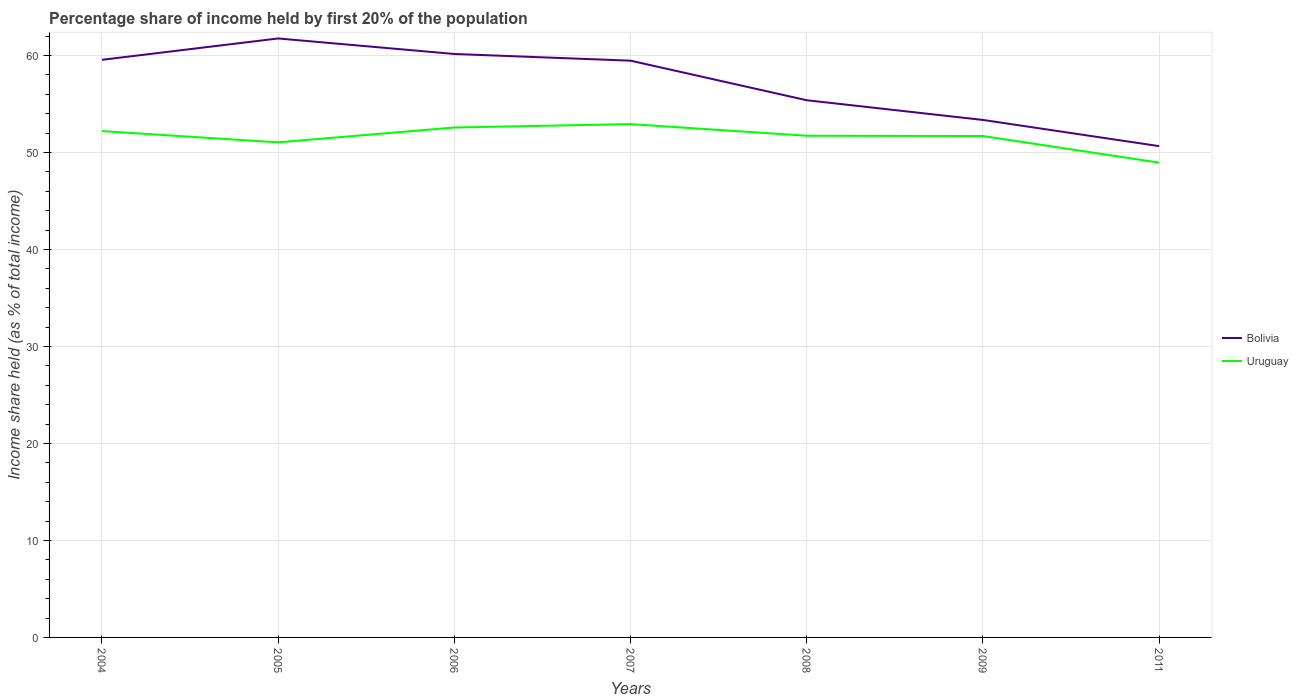How many different coloured lines are there?
Provide a succinct answer. 2. Does the line corresponding to Uruguay intersect with the line corresponding to Bolivia?
Provide a short and direct response. No. Across all years, what is the maximum share of income held by first 20% of the population in Uruguay?
Ensure brevity in your answer.  48.95. In which year was the share of income held by first 20% of the population in Bolivia maximum?
Your answer should be very brief. 2011. What is the total share of income held by first 20% of the population in Bolivia in the graph?
Your response must be concise. 0.09. What is the difference between the highest and the second highest share of income held by first 20% of the population in Uruguay?
Offer a very short reply. 3.97. Is the share of income held by first 20% of the population in Uruguay strictly greater than the share of income held by first 20% of the population in Bolivia over the years?
Provide a short and direct response. Yes. How many lines are there?
Offer a very short reply. 2. What is the difference between two consecutive major ticks on the Y-axis?
Your response must be concise. 10. Does the graph contain any zero values?
Your answer should be compact. No. Where does the legend appear in the graph?
Your answer should be compact. Center right. What is the title of the graph?
Keep it short and to the point. Percentage share of income held by first 20% of the population. What is the label or title of the X-axis?
Your answer should be compact. Years. What is the label or title of the Y-axis?
Ensure brevity in your answer.  Income share held (as % of total income). What is the Income share held (as % of total income) of Bolivia in 2004?
Make the answer very short. 59.55. What is the Income share held (as % of total income) of Uruguay in 2004?
Give a very brief answer. 52.2. What is the Income share held (as % of total income) in Bolivia in 2005?
Offer a terse response. 61.75. What is the Income share held (as % of total income) of Uruguay in 2005?
Keep it short and to the point. 51.04. What is the Income share held (as % of total income) of Bolivia in 2006?
Provide a succinct answer. 60.15. What is the Income share held (as % of total income) in Uruguay in 2006?
Provide a short and direct response. 52.57. What is the Income share held (as % of total income) of Bolivia in 2007?
Give a very brief answer. 59.46. What is the Income share held (as % of total income) of Uruguay in 2007?
Provide a short and direct response. 52.92. What is the Income share held (as % of total income) in Bolivia in 2008?
Make the answer very short. 55.38. What is the Income share held (as % of total income) in Uruguay in 2008?
Ensure brevity in your answer.  51.72. What is the Income share held (as % of total income) of Bolivia in 2009?
Make the answer very short. 53.35. What is the Income share held (as % of total income) in Uruguay in 2009?
Provide a short and direct response. 51.69. What is the Income share held (as % of total income) in Bolivia in 2011?
Your answer should be very brief. 50.65. What is the Income share held (as % of total income) in Uruguay in 2011?
Ensure brevity in your answer.  48.95. Across all years, what is the maximum Income share held (as % of total income) of Bolivia?
Ensure brevity in your answer.  61.75. Across all years, what is the maximum Income share held (as % of total income) in Uruguay?
Offer a very short reply. 52.92. Across all years, what is the minimum Income share held (as % of total income) in Bolivia?
Offer a terse response. 50.65. Across all years, what is the minimum Income share held (as % of total income) in Uruguay?
Ensure brevity in your answer.  48.95. What is the total Income share held (as % of total income) of Bolivia in the graph?
Offer a terse response. 400.29. What is the total Income share held (as % of total income) of Uruguay in the graph?
Give a very brief answer. 361.09. What is the difference between the Income share held (as % of total income) in Uruguay in 2004 and that in 2005?
Ensure brevity in your answer.  1.16. What is the difference between the Income share held (as % of total income) of Uruguay in 2004 and that in 2006?
Your answer should be very brief. -0.37. What is the difference between the Income share held (as % of total income) in Bolivia in 2004 and that in 2007?
Your response must be concise. 0.09. What is the difference between the Income share held (as % of total income) in Uruguay in 2004 and that in 2007?
Give a very brief answer. -0.72. What is the difference between the Income share held (as % of total income) of Bolivia in 2004 and that in 2008?
Give a very brief answer. 4.17. What is the difference between the Income share held (as % of total income) in Uruguay in 2004 and that in 2008?
Offer a very short reply. 0.48. What is the difference between the Income share held (as % of total income) in Bolivia in 2004 and that in 2009?
Your response must be concise. 6.2. What is the difference between the Income share held (as % of total income) in Uruguay in 2004 and that in 2009?
Offer a terse response. 0.51. What is the difference between the Income share held (as % of total income) in Uruguay in 2004 and that in 2011?
Your answer should be compact. 3.25. What is the difference between the Income share held (as % of total income) in Uruguay in 2005 and that in 2006?
Offer a terse response. -1.53. What is the difference between the Income share held (as % of total income) in Bolivia in 2005 and that in 2007?
Your response must be concise. 2.29. What is the difference between the Income share held (as % of total income) in Uruguay in 2005 and that in 2007?
Give a very brief answer. -1.88. What is the difference between the Income share held (as % of total income) of Bolivia in 2005 and that in 2008?
Give a very brief answer. 6.37. What is the difference between the Income share held (as % of total income) in Uruguay in 2005 and that in 2008?
Provide a short and direct response. -0.68. What is the difference between the Income share held (as % of total income) in Uruguay in 2005 and that in 2009?
Your answer should be compact. -0.65. What is the difference between the Income share held (as % of total income) in Uruguay in 2005 and that in 2011?
Ensure brevity in your answer.  2.09. What is the difference between the Income share held (as % of total income) of Bolivia in 2006 and that in 2007?
Offer a very short reply. 0.69. What is the difference between the Income share held (as % of total income) of Uruguay in 2006 and that in 2007?
Offer a terse response. -0.35. What is the difference between the Income share held (as % of total income) of Bolivia in 2006 and that in 2008?
Your response must be concise. 4.77. What is the difference between the Income share held (as % of total income) of Uruguay in 2006 and that in 2008?
Keep it short and to the point. 0.85. What is the difference between the Income share held (as % of total income) in Uruguay in 2006 and that in 2009?
Your answer should be very brief. 0.88. What is the difference between the Income share held (as % of total income) in Uruguay in 2006 and that in 2011?
Keep it short and to the point. 3.62. What is the difference between the Income share held (as % of total income) of Bolivia in 2007 and that in 2008?
Make the answer very short. 4.08. What is the difference between the Income share held (as % of total income) of Uruguay in 2007 and that in 2008?
Give a very brief answer. 1.2. What is the difference between the Income share held (as % of total income) in Bolivia in 2007 and that in 2009?
Give a very brief answer. 6.11. What is the difference between the Income share held (as % of total income) in Uruguay in 2007 and that in 2009?
Your answer should be compact. 1.23. What is the difference between the Income share held (as % of total income) in Bolivia in 2007 and that in 2011?
Provide a succinct answer. 8.81. What is the difference between the Income share held (as % of total income) in Uruguay in 2007 and that in 2011?
Your response must be concise. 3.97. What is the difference between the Income share held (as % of total income) in Bolivia in 2008 and that in 2009?
Give a very brief answer. 2.03. What is the difference between the Income share held (as % of total income) in Bolivia in 2008 and that in 2011?
Give a very brief answer. 4.73. What is the difference between the Income share held (as % of total income) in Uruguay in 2008 and that in 2011?
Give a very brief answer. 2.77. What is the difference between the Income share held (as % of total income) in Bolivia in 2009 and that in 2011?
Provide a short and direct response. 2.7. What is the difference between the Income share held (as % of total income) in Uruguay in 2009 and that in 2011?
Ensure brevity in your answer.  2.74. What is the difference between the Income share held (as % of total income) of Bolivia in 2004 and the Income share held (as % of total income) of Uruguay in 2005?
Provide a succinct answer. 8.51. What is the difference between the Income share held (as % of total income) of Bolivia in 2004 and the Income share held (as % of total income) of Uruguay in 2006?
Offer a very short reply. 6.98. What is the difference between the Income share held (as % of total income) in Bolivia in 2004 and the Income share held (as % of total income) in Uruguay in 2007?
Provide a succinct answer. 6.63. What is the difference between the Income share held (as % of total income) in Bolivia in 2004 and the Income share held (as % of total income) in Uruguay in 2008?
Your response must be concise. 7.83. What is the difference between the Income share held (as % of total income) in Bolivia in 2004 and the Income share held (as % of total income) in Uruguay in 2009?
Give a very brief answer. 7.86. What is the difference between the Income share held (as % of total income) of Bolivia in 2004 and the Income share held (as % of total income) of Uruguay in 2011?
Offer a very short reply. 10.6. What is the difference between the Income share held (as % of total income) of Bolivia in 2005 and the Income share held (as % of total income) of Uruguay in 2006?
Keep it short and to the point. 9.18. What is the difference between the Income share held (as % of total income) of Bolivia in 2005 and the Income share held (as % of total income) of Uruguay in 2007?
Your answer should be very brief. 8.83. What is the difference between the Income share held (as % of total income) of Bolivia in 2005 and the Income share held (as % of total income) of Uruguay in 2008?
Provide a succinct answer. 10.03. What is the difference between the Income share held (as % of total income) in Bolivia in 2005 and the Income share held (as % of total income) in Uruguay in 2009?
Provide a succinct answer. 10.06. What is the difference between the Income share held (as % of total income) in Bolivia in 2006 and the Income share held (as % of total income) in Uruguay in 2007?
Give a very brief answer. 7.23. What is the difference between the Income share held (as % of total income) of Bolivia in 2006 and the Income share held (as % of total income) of Uruguay in 2008?
Provide a short and direct response. 8.43. What is the difference between the Income share held (as % of total income) in Bolivia in 2006 and the Income share held (as % of total income) in Uruguay in 2009?
Offer a terse response. 8.46. What is the difference between the Income share held (as % of total income) in Bolivia in 2006 and the Income share held (as % of total income) in Uruguay in 2011?
Your answer should be compact. 11.2. What is the difference between the Income share held (as % of total income) in Bolivia in 2007 and the Income share held (as % of total income) in Uruguay in 2008?
Offer a terse response. 7.74. What is the difference between the Income share held (as % of total income) in Bolivia in 2007 and the Income share held (as % of total income) in Uruguay in 2009?
Your answer should be compact. 7.77. What is the difference between the Income share held (as % of total income) of Bolivia in 2007 and the Income share held (as % of total income) of Uruguay in 2011?
Give a very brief answer. 10.51. What is the difference between the Income share held (as % of total income) of Bolivia in 2008 and the Income share held (as % of total income) of Uruguay in 2009?
Your answer should be very brief. 3.69. What is the difference between the Income share held (as % of total income) in Bolivia in 2008 and the Income share held (as % of total income) in Uruguay in 2011?
Give a very brief answer. 6.43. What is the difference between the Income share held (as % of total income) of Bolivia in 2009 and the Income share held (as % of total income) of Uruguay in 2011?
Your answer should be very brief. 4.4. What is the average Income share held (as % of total income) of Bolivia per year?
Your response must be concise. 57.18. What is the average Income share held (as % of total income) in Uruguay per year?
Provide a short and direct response. 51.58. In the year 2004, what is the difference between the Income share held (as % of total income) in Bolivia and Income share held (as % of total income) in Uruguay?
Provide a short and direct response. 7.35. In the year 2005, what is the difference between the Income share held (as % of total income) in Bolivia and Income share held (as % of total income) in Uruguay?
Offer a very short reply. 10.71. In the year 2006, what is the difference between the Income share held (as % of total income) in Bolivia and Income share held (as % of total income) in Uruguay?
Offer a very short reply. 7.58. In the year 2007, what is the difference between the Income share held (as % of total income) of Bolivia and Income share held (as % of total income) of Uruguay?
Keep it short and to the point. 6.54. In the year 2008, what is the difference between the Income share held (as % of total income) of Bolivia and Income share held (as % of total income) of Uruguay?
Your answer should be very brief. 3.66. In the year 2009, what is the difference between the Income share held (as % of total income) in Bolivia and Income share held (as % of total income) in Uruguay?
Offer a terse response. 1.66. What is the ratio of the Income share held (as % of total income) in Bolivia in 2004 to that in 2005?
Your response must be concise. 0.96. What is the ratio of the Income share held (as % of total income) of Uruguay in 2004 to that in 2005?
Your answer should be very brief. 1.02. What is the ratio of the Income share held (as % of total income) of Uruguay in 2004 to that in 2007?
Make the answer very short. 0.99. What is the ratio of the Income share held (as % of total income) of Bolivia in 2004 to that in 2008?
Offer a terse response. 1.08. What is the ratio of the Income share held (as % of total income) of Uruguay in 2004 to that in 2008?
Ensure brevity in your answer.  1.01. What is the ratio of the Income share held (as % of total income) in Bolivia in 2004 to that in 2009?
Ensure brevity in your answer.  1.12. What is the ratio of the Income share held (as % of total income) of Uruguay in 2004 to that in 2009?
Give a very brief answer. 1.01. What is the ratio of the Income share held (as % of total income) of Bolivia in 2004 to that in 2011?
Your answer should be compact. 1.18. What is the ratio of the Income share held (as % of total income) in Uruguay in 2004 to that in 2011?
Your answer should be compact. 1.07. What is the ratio of the Income share held (as % of total income) in Bolivia in 2005 to that in 2006?
Offer a terse response. 1.03. What is the ratio of the Income share held (as % of total income) in Uruguay in 2005 to that in 2006?
Provide a short and direct response. 0.97. What is the ratio of the Income share held (as % of total income) of Bolivia in 2005 to that in 2007?
Provide a short and direct response. 1.04. What is the ratio of the Income share held (as % of total income) in Uruguay in 2005 to that in 2007?
Offer a terse response. 0.96. What is the ratio of the Income share held (as % of total income) in Bolivia in 2005 to that in 2008?
Give a very brief answer. 1.11. What is the ratio of the Income share held (as % of total income) of Uruguay in 2005 to that in 2008?
Offer a terse response. 0.99. What is the ratio of the Income share held (as % of total income) of Bolivia in 2005 to that in 2009?
Give a very brief answer. 1.16. What is the ratio of the Income share held (as % of total income) in Uruguay in 2005 to that in 2009?
Provide a short and direct response. 0.99. What is the ratio of the Income share held (as % of total income) of Bolivia in 2005 to that in 2011?
Provide a short and direct response. 1.22. What is the ratio of the Income share held (as % of total income) in Uruguay in 2005 to that in 2011?
Your response must be concise. 1.04. What is the ratio of the Income share held (as % of total income) of Bolivia in 2006 to that in 2007?
Ensure brevity in your answer.  1.01. What is the ratio of the Income share held (as % of total income) in Bolivia in 2006 to that in 2008?
Your response must be concise. 1.09. What is the ratio of the Income share held (as % of total income) of Uruguay in 2006 to that in 2008?
Give a very brief answer. 1.02. What is the ratio of the Income share held (as % of total income) of Bolivia in 2006 to that in 2009?
Offer a very short reply. 1.13. What is the ratio of the Income share held (as % of total income) of Bolivia in 2006 to that in 2011?
Your response must be concise. 1.19. What is the ratio of the Income share held (as % of total income) of Uruguay in 2006 to that in 2011?
Your answer should be very brief. 1.07. What is the ratio of the Income share held (as % of total income) in Bolivia in 2007 to that in 2008?
Keep it short and to the point. 1.07. What is the ratio of the Income share held (as % of total income) in Uruguay in 2007 to that in 2008?
Offer a terse response. 1.02. What is the ratio of the Income share held (as % of total income) of Bolivia in 2007 to that in 2009?
Your answer should be very brief. 1.11. What is the ratio of the Income share held (as % of total income) of Uruguay in 2007 to that in 2009?
Your response must be concise. 1.02. What is the ratio of the Income share held (as % of total income) in Bolivia in 2007 to that in 2011?
Offer a very short reply. 1.17. What is the ratio of the Income share held (as % of total income) in Uruguay in 2007 to that in 2011?
Give a very brief answer. 1.08. What is the ratio of the Income share held (as % of total income) of Bolivia in 2008 to that in 2009?
Offer a terse response. 1.04. What is the ratio of the Income share held (as % of total income) of Bolivia in 2008 to that in 2011?
Your answer should be compact. 1.09. What is the ratio of the Income share held (as % of total income) of Uruguay in 2008 to that in 2011?
Give a very brief answer. 1.06. What is the ratio of the Income share held (as % of total income) in Bolivia in 2009 to that in 2011?
Your answer should be very brief. 1.05. What is the ratio of the Income share held (as % of total income) in Uruguay in 2009 to that in 2011?
Your answer should be compact. 1.06. What is the difference between the highest and the second highest Income share held (as % of total income) in Bolivia?
Make the answer very short. 1.6. What is the difference between the highest and the lowest Income share held (as % of total income) in Bolivia?
Ensure brevity in your answer.  11.1. What is the difference between the highest and the lowest Income share held (as % of total income) in Uruguay?
Make the answer very short. 3.97. 